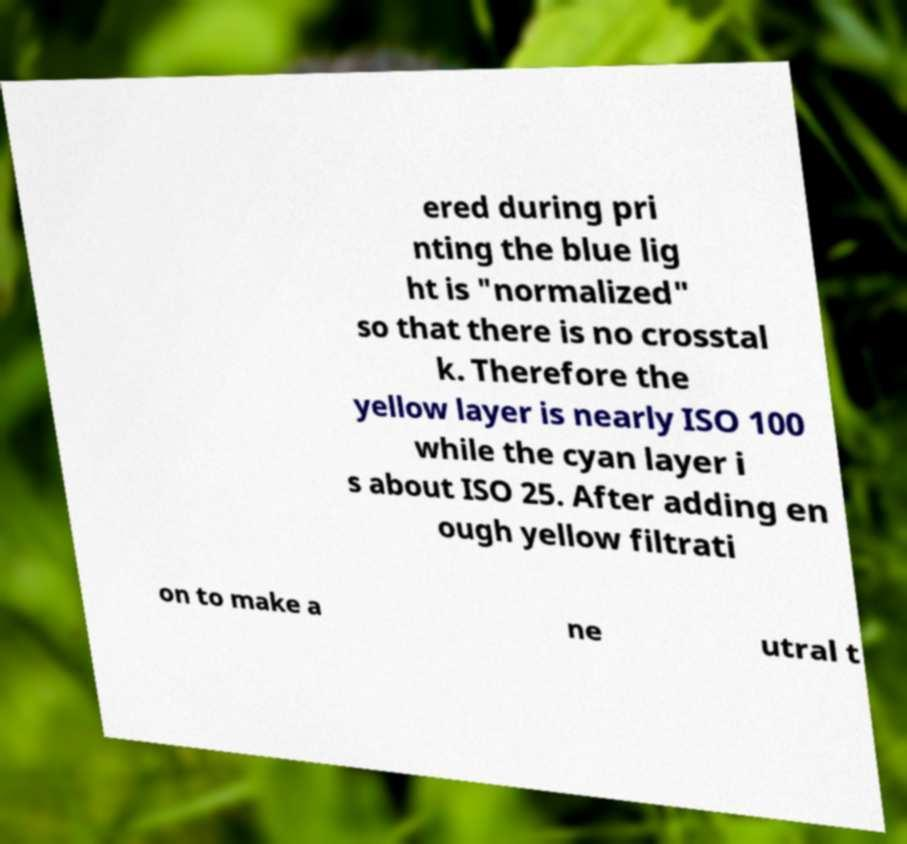There's text embedded in this image that I need extracted. Can you transcribe it verbatim? ered during pri nting the blue lig ht is "normalized" so that there is no crosstal k. Therefore the yellow layer is nearly ISO 100 while the cyan layer i s about ISO 25. After adding en ough yellow filtrati on to make a ne utral t 